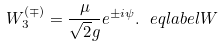Convert formula to latex. <formula><loc_0><loc_0><loc_500><loc_500>W ^ { ( \mp ) } _ { 3 } = \frac { \mu } { \sqrt { 2 } g } e ^ { \pm i \psi } . \ e q l a b e l { W }</formula> 